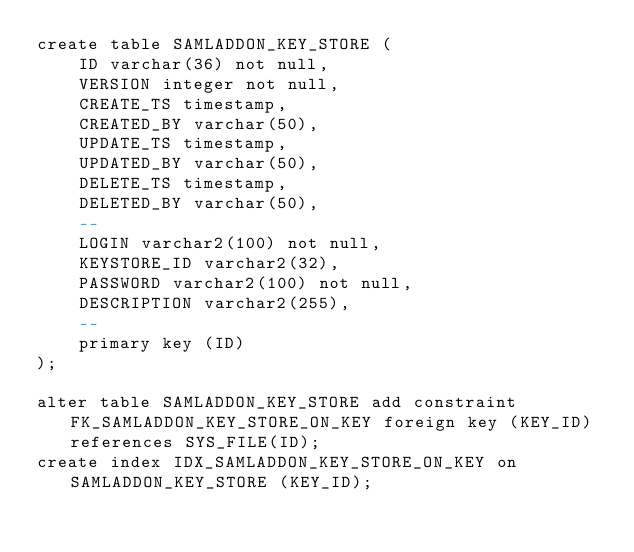<code> <loc_0><loc_0><loc_500><loc_500><_SQL_>create table SAMLADDON_KEY_STORE (
    ID varchar(36) not null,
    VERSION integer not null,
    CREATE_TS timestamp,
    CREATED_BY varchar(50),
    UPDATE_TS timestamp,
    UPDATED_BY varchar(50),
    DELETE_TS timestamp,
    DELETED_BY varchar(50),
    --
    LOGIN varchar2(100) not null,
    KEYSTORE_ID varchar2(32),
    PASSWORD varchar2(100) not null,
    DESCRIPTION varchar2(255),
    --
    primary key (ID)
);

alter table SAMLADDON_KEY_STORE add constraint FK_SAMLADDON_KEY_STORE_ON_KEY foreign key (KEY_ID) references SYS_FILE(ID);
create index IDX_SAMLADDON_KEY_STORE_ON_KEY on SAMLADDON_KEY_STORE (KEY_ID);

</code> 